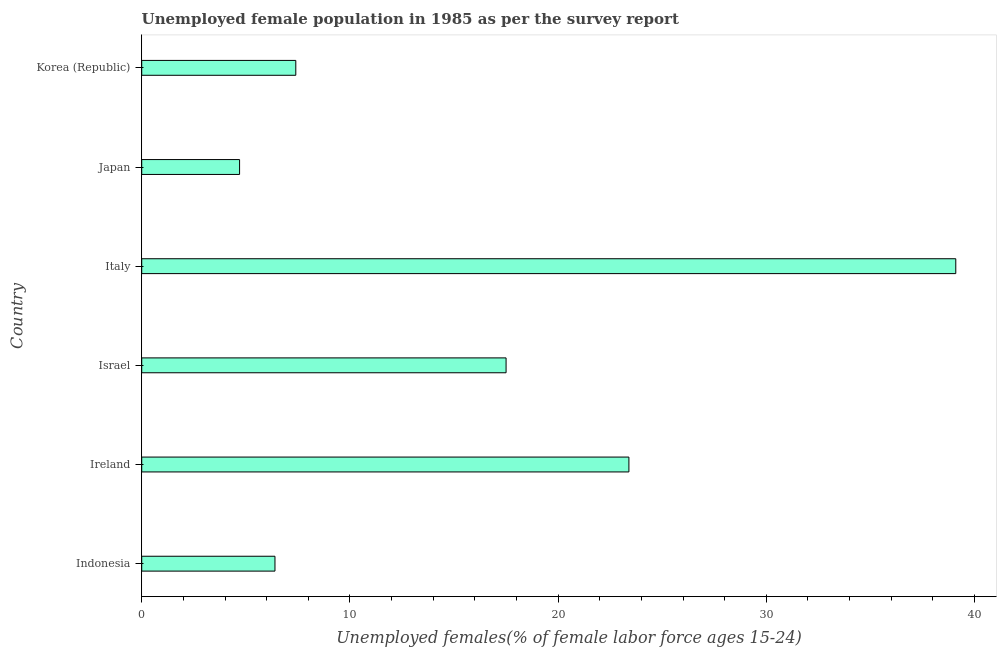Does the graph contain any zero values?
Make the answer very short. No. What is the title of the graph?
Offer a terse response. Unemployed female population in 1985 as per the survey report. What is the label or title of the X-axis?
Make the answer very short. Unemployed females(% of female labor force ages 15-24). What is the unemployed female youth in Japan?
Provide a succinct answer. 4.7. Across all countries, what is the maximum unemployed female youth?
Your answer should be compact. 39.1. Across all countries, what is the minimum unemployed female youth?
Make the answer very short. 4.7. In which country was the unemployed female youth maximum?
Offer a terse response. Italy. In which country was the unemployed female youth minimum?
Your answer should be very brief. Japan. What is the sum of the unemployed female youth?
Provide a succinct answer. 98.5. What is the average unemployed female youth per country?
Ensure brevity in your answer.  16.42. What is the median unemployed female youth?
Provide a short and direct response. 12.45. What is the ratio of the unemployed female youth in Indonesia to that in Israel?
Provide a short and direct response. 0.37. Is the unemployed female youth in Indonesia less than that in Israel?
Offer a terse response. Yes. Is the difference between the unemployed female youth in Japan and Korea (Republic) greater than the difference between any two countries?
Ensure brevity in your answer.  No. Is the sum of the unemployed female youth in Japan and Korea (Republic) greater than the maximum unemployed female youth across all countries?
Provide a short and direct response. No. What is the difference between the highest and the lowest unemployed female youth?
Your answer should be very brief. 34.4. In how many countries, is the unemployed female youth greater than the average unemployed female youth taken over all countries?
Offer a very short reply. 3. How many bars are there?
Your answer should be compact. 6. How many countries are there in the graph?
Keep it short and to the point. 6. What is the difference between two consecutive major ticks on the X-axis?
Ensure brevity in your answer.  10. What is the Unemployed females(% of female labor force ages 15-24) of Indonesia?
Make the answer very short. 6.4. What is the Unemployed females(% of female labor force ages 15-24) in Ireland?
Provide a short and direct response. 23.4. What is the Unemployed females(% of female labor force ages 15-24) of Italy?
Your response must be concise. 39.1. What is the Unemployed females(% of female labor force ages 15-24) of Japan?
Make the answer very short. 4.7. What is the Unemployed females(% of female labor force ages 15-24) of Korea (Republic)?
Offer a very short reply. 7.4. What is the difference between the Unemployed females(% of female labor force ages 15-24) in Indonesia and Italy?
Keep it short and to the point. -32.7. What is the difference between the Unemployed females(% of female labor force ages 15-24) in Indonesia and Korea (Republic)?
Provide a short and direct response. -1. What is the difference between the Unemployed females(% of female labor force ages 15-24) in Ireland and Italy?
Your answer should be compact. -15.7. What is the difference between the Unemployed females(% of female labor force ages 15-24) in Israel and Italy?
Provide a succinct answer. -21.6. What is the difference between the Unemployed females(% of female labor force ages 15-24) in Israel and Japan?
Offer a terse response. 12.8. What is the difference between the Unemployed females(% of female labor force ages 15-24) in Italy and Japan?
Your answer should be compact. 34.4. What is the difference between the Unemployed females(% of female labor force ages 15-24) in Italy and Korea (Republic)?
Offer a terse response. 31.7. What is the difference between the Unemployed females(% of female labor force ages 15-24) in Japan and Korea (Republic)?
Offer a very short reply. -2.7. What is the ratio of the Unemployed females(% of female labor force ages 15-24) in Indonesia to that in Ireland?
Your response must be concise. 0.27. What is the ratio of the Unemployed females(% of female labor force ages 15-24) in Indonesia to that in Israel?
Your answer should be compact. 0.37. What is the ratio of the Unemployed females(% of female labor force ages 15-24) in Indonesia to that in Italy?
Your response must be concise. 0.16. What is the ratio of the Unemployed females(% of female labor force ages 15-24) in Indonesia to that in Japan?
Your answer should be compact. 1.36. What is the ratio of the Unemployed females(% of female labor force ages 15-24) in Indonesia to that in Korea (Republic)?
Make the answer very short. 0.86. What is the ratio of the Unemployed females(% of female labor force ages 15-24) in Ireland to that in Israel?
Provide a succinct answer. 1.34. What is the ratio of the Unemployed females(% of female labor force ages 15-24) in Ireland to that in Italy?
Provide a succinct answer. 0.6. What is the ratio of the Unemployed females(% of female labor force ages 15-24) in Ireland to that in Japan?
Make the answer very short. 4.98. What is the ratio of the Unemployed females(% of female labor force ages 15-24) in Ireland to that in Korea (Republic)?
Offer a very short reply. 3.16. What is the ratio of the Unemployed females(% of female labor force ages 15-24) in Israel to that in Italy?
Your answer should be very brief. 0.45. What is the ratio of the Unemployed females(% of female labor force ages 15-24) in Israel to that in Japan?
Your answer should be compact. 3.72. What is the ratio of the Unemployed females(% of female labor force ages 15-24) in Israel to that in Korea (Republic)?
Keep it short and to the point. 2.37. What is the ratio of the Unemployed females(% of female labor force ages 15-24) in Italy to that in Japan?
Offer a terse response. 8.32. What is the ratio of the Unemployed females(% of female labor force ages 15-24) in Italy to that in Korea (Republic)?
Provide a short and direct response. 5.28. What is the ratio of the Unemployed females(% of female labor force ages 15-24) in Japan to that in Korea (Republic)?
Make the answer very short. 0.64. 